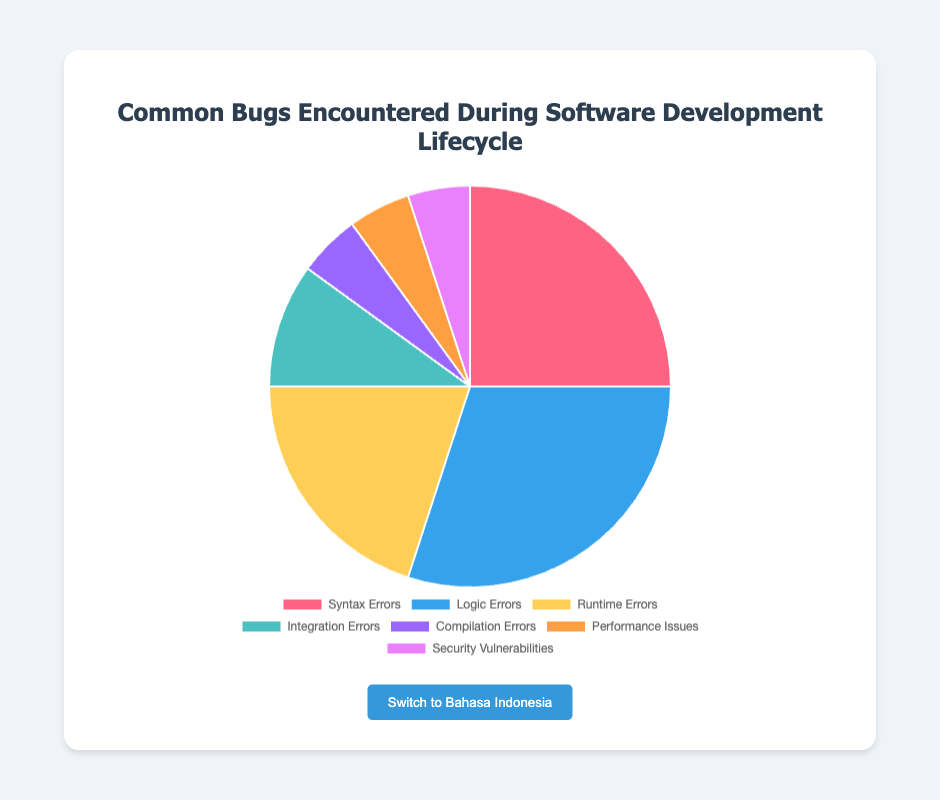Which category has the highest percentage of bugs? The figure shows that Logic Errors have the highest percentage among the categories listed.
Answer: Logic Errors Which category has the lowest percentage of bugs? The figure indicates that Compilation Errors, Performance Issues, and Security Vulnerabilities each have the lowest percentage, all with 5%.
Answer: Compilation Errors, Performance Issues, Security Vulnerabilities What is the combined percentage of Syntax Errors and Integration Errors? To find the combined percentage, add the percentage of Syntax Errors (25%) and Integration Errors (10%). Thus, 25 + 10 = 35%.
Answer: 35% How does the percentage of Runtime Errors compare to Performance Issues? The figure shows that Runtime Errors have a higher percentage (20%) compared to Performance Issues (5%).
Answer: Runtime Errors > Performance Issues What is the difference in percentage between Logic Errors and Syntax Errors? Subtract the percentage of Syntax Errors (25%) from the percentage of Logic Errors (30%). Thus, 30 - 25 = 5%.
Answer: 5% What is the total percentage covered by Logic Errors, Runtime Errors, and Integration Errors? Add the percentages of Logic Errors (30%), Runtime Errors (20%), and Integration Errors (10%). Thus, 30 + 20 + 10 = 60%.
Answer: 60% What percentage of bugs are listed under Performance Issues and Security Vulnerabilities combined? Combine the percentages of Performance Issues (5%) and Security Vulnerabilities (5%). Thus, 5 + 5 = 10%.
Answer: 10% Which category is represented by the blue color? By looking at the colors associated with each category in the figure, the blue color represents Logic Errors.
Answer: Logic Errors 